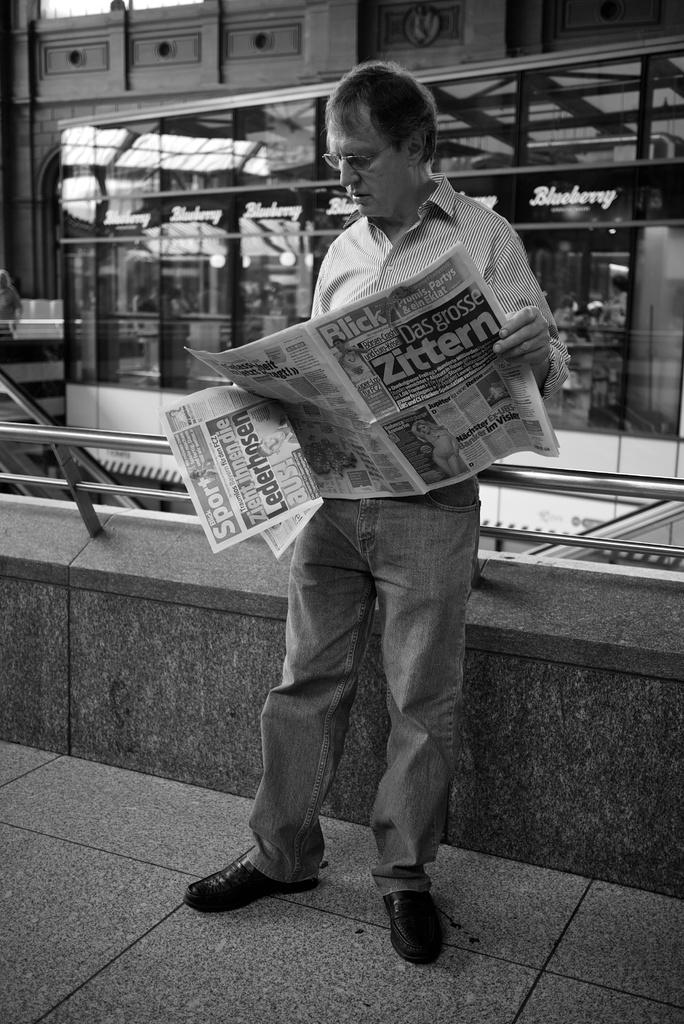What is the person in the image doing? The person is standing in the image and holding a paper. What can be seen in the background of the image? There is a building in the background of the image. What architectural feature is present in the image? There is a railing on a wall in the image. What surface is visible in the image? There is a floor visible in the image. What type of bean is growing on the person's chin in the image? There is no bean growing on the person's chin in the image. 